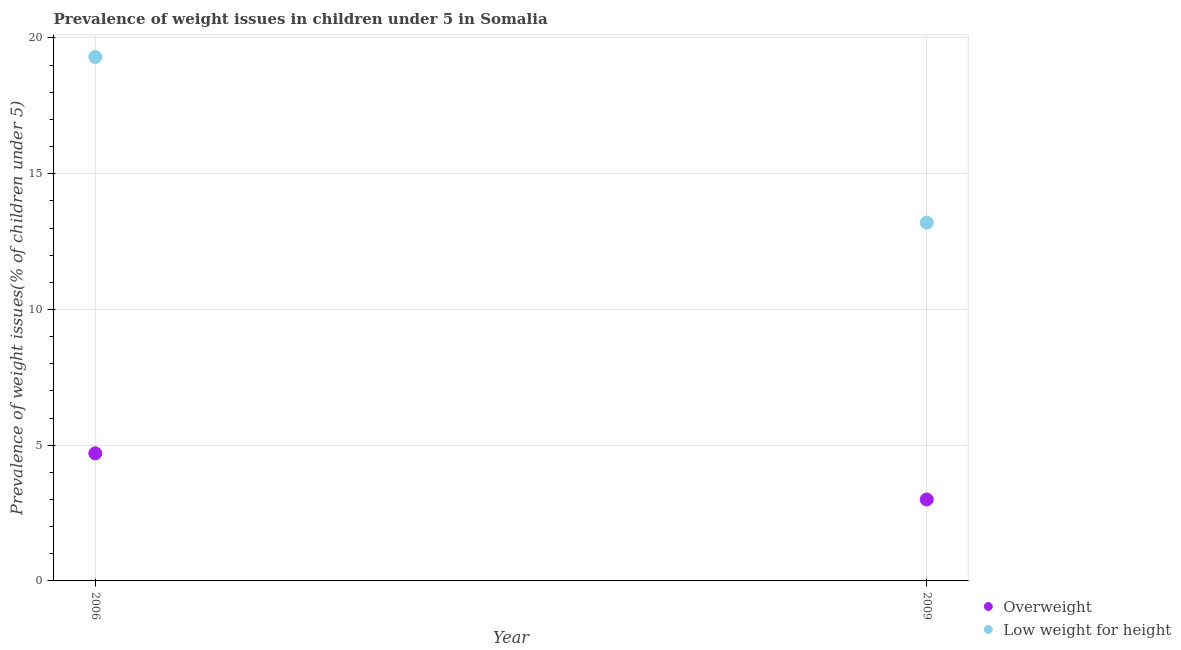What is the percentage of underweight children in 2009?
Ensure brevity in your answer.  13.2. Across all years, what is the maximum percentage of overweight children?
Offer a very short reply. 4.7. In which year was the percentage of overweight children maximum?
Your response must be concise. 2006. In which year was the percentage of underweight children minimum?
Your response must be concise. 2009. What is the total percentage of underweight children in the graph?
Provide a short and direct response. 32.5. What is the difference between the percentage of underweight children in 2006 and that in 2009?
Give a very brief answer. 6.1. What is the difference between the percentage of underweight children in 2006 and the percentage of overweight children in 2009?
Offer a very short reply. 16.3. What is the average percentage of underweight children per year?
Ensure brevity in your answer.  16.25. In the year 2006, what is the difference between the percentage of underweight children and percentage of overweight children?
Your response must be concise. 14.6. In how many years, is the percentage of overweight children greater than 2 %?
Your response must be concise. 2. What is the ratio of the percentage of underweight children in 2006 to that in 2009?
Your response must be concise. 1.46. Is the percentage of overweight children strictly less than the percentage of underweight children over the years?
Give a very brief answer. Yes. How many dotlines are there?
Your answer should be compact. 2. How many years are there in the graph?
Ensure brevity in your answer.  2. Where does the legend appear in the graph?
Make the answer very short. Bottom right. How many legend labels are there?
Make the answer very short. 2. How are the legend labels stacked?
Offer a terse response. Vertical. What is the title of the graph?
Offer a terse response. Prevalence of weight issues in children under 5 in Somalia. Does "Chemicals" appear as one of the legend labels in the graph?
Keep it short and to the point. No. What is the label or title of the X-axis?
Offer a very short reply. Year. What is the label or title of the Y-axis?
Your response must be concise. Prevalence of weight issues(% of children under 5). What is the Prevalence of weight issues(% of children under 5) in Overweight in 2006?
Give a very brief answer. 4.7. What is the Prevalence of weight issues(% of children under 5) of Low weight for height in 2006?
Make the answer very short. 19.3. What is the Prevalence of weight issues(% of children under 5) of Overweight in 2009?
Make the answer very short. 3. What is the Prevalence of weight issues(% of children under 5) in Low weight for height in 2009?
Keep it short and to the point. 13.2. Across all years, what is the maximum Prevalence of weight issues(% of children under 5) of Overweight?
Provide a succinct answer. 4.7. Across all years, what is the maximum Prevalence of weight issues(% of children under 5) in Low weight for height?
Keep it short and to the point. 19.3. Across all years, what is the minimum Prevalence of weight issues(% of children under 5) in Overweight?
Provide a succinct answer. 3. Across all years, what is the minimum Prevalence of weight issues(% of children under 5) in Low weight for height?
Your response must be concise. 13.2. What is the total Prevalence of weight issues(% of children under 5) of Overweight in the graph?
Make the answer very short. 7.7. What is the total Prevalence of weight issues(% of children under 5) in Low weight for height in the graph?
Keep it short and to the point. 32.5. What is the difference between the Prevalence of weight issues(% of children under 5) of Overweight in 2006 and that in 2009?
Your answer should be compact. 1.7. What is the difference between the Prevalence of weight issues(% of children under 5) of Overweight in 2006 and the Prevalence of weight issues(% of children under 5) of Low weight for height in 2009?
Provide a succinct answer. -8.5. What is the average Prevalence of weight issues(% of children under 5) in Overweight per year?
Your answer should be compact. 3.85. What is the average Prevalence of weight issues(% of children under 5) of Low weight for height per year?
Offer a terse response. 16.25. In the year 2006, what is the difference between the Prevalence of weight issues(% of children under 5) in Overweight and Prevalence of weight issues(% of children under 5) in Low weight for height?
Provide a short and direct response. -14.6. In the year 2009, what is the difference between the Prevalence of weight issues(% of children under 5) of Overweight and Prevalence of weight issues(% of children under 5) of Low weight for height?
Provide a short and direct response. -10.2. What is the ratio of the Prevalence of weight issues(% of children under 5) of Overweight in 2006 to that in 2009?
Ensure brevity in your answer.  1.57. What is the ratio of the Prevalence of weight issues(% of children under 5) of Low weight for height in 2006 to that in 2009?
Provide a succinct answer. 1.46. What is the difference between the highest and the second highest Prevalence of weight issues(% of children under 5) of Overweight?
Provide a short and direct response. 1.7. 